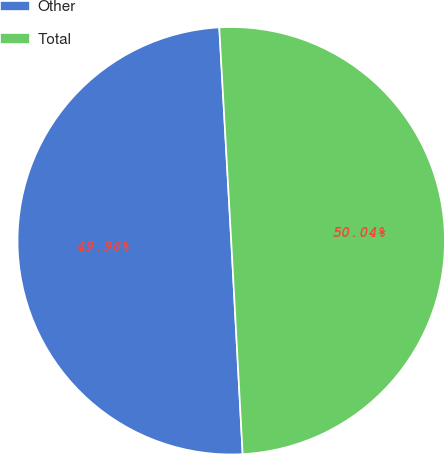<chart> <loc_0><loc_0><loc_500><loc_500><pie_chart><fcel>Other<fcel>Total<nl><fcel>49.96%<fcel>50.04%<nl></chart> 